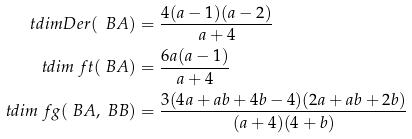Convert formula to latex. <formula><loc_0><loc_0><loc_500><loc_500>\ t d i m D e r ( \ B A ) & = \frac { 4 ( a - 1 ) ( a - 2 ) } { a + 4 } \\ \ t d i m \ f t ( \ B A ) & = \frac { 6 a ( a - 1 ) } { a + 4 } \\ \ t d i m \ f g ( \ B A , \ B B ) & = \frac { 3 ( 4 a + a b + 4 b - 4 ) ( 2 a + a b + 2 b ) } { ( a + 4 ) ( 4 + b ) }</formula> 